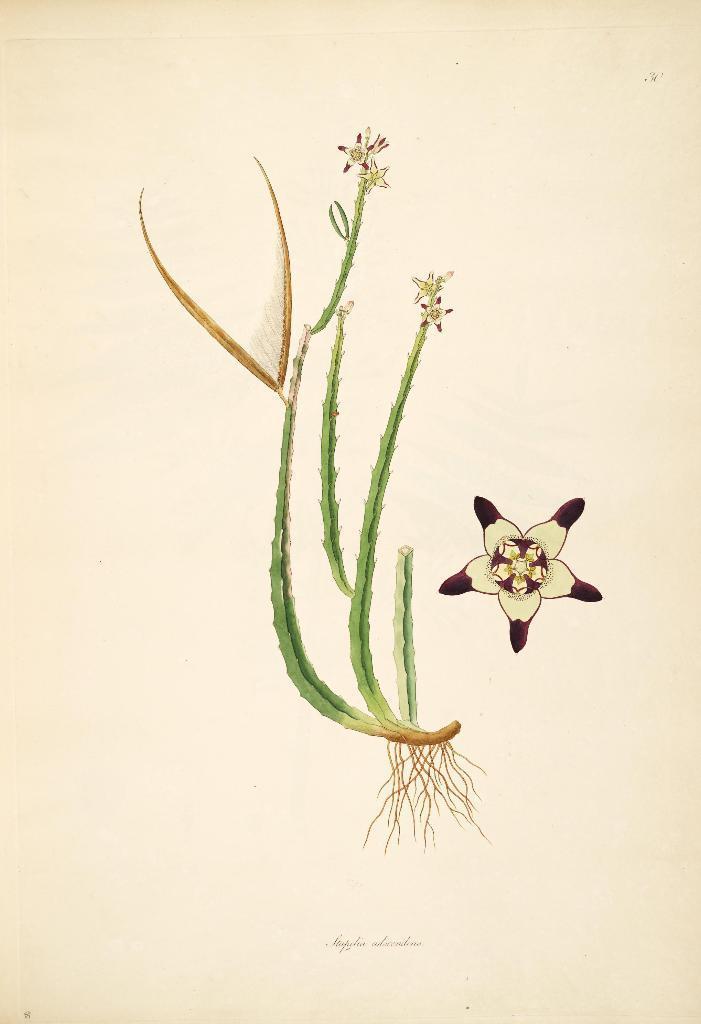Can you describe this image briefly? In this image I can see a plant which is green and brown in color and I can see few flowers to it which are white and pink in color. To the bottom of the plant I can see its roots which are brown in color. I can see a flower which is dark pink and white in color and the cream colored background. 